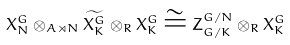<formula> <loc_0><loc_0><loc_500><loc_500>X _ { N } ^ { G } \otimes _ { A \rtimes N } \widetilde { X _ { K } ^ { G } } \otimes _ { R } X _ { K } ^ { G } \cong Z _ { G / K } ^ { G / N } \otimes _ { R } X _ { K } ^ { G }</formula> 